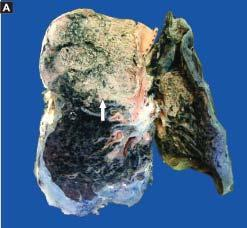s the infiltrate in the lumina composed of neutrophils and macrophages?
Answer the question using a single word or phrase. Yes 